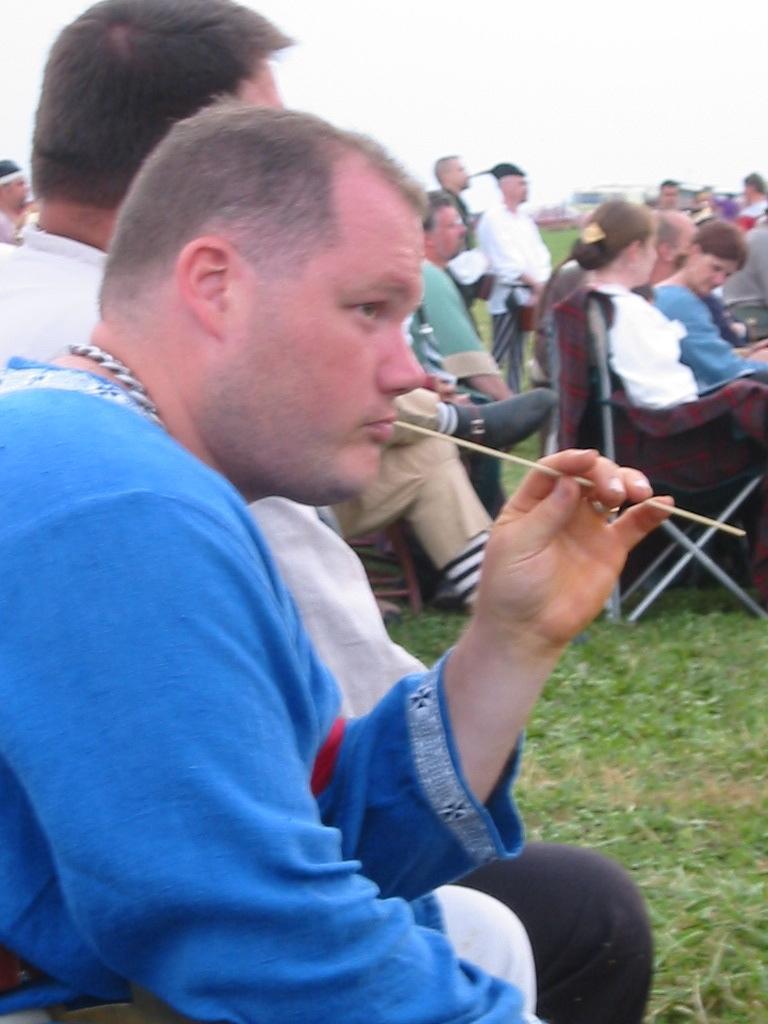How would you summarize this image in a sentence or two? In the image on the left we can see two persons were sitting and the front person is holding stick. In the background we can see sky,clouds,building,grass,few peoples were sitting and few peoples were standing. 